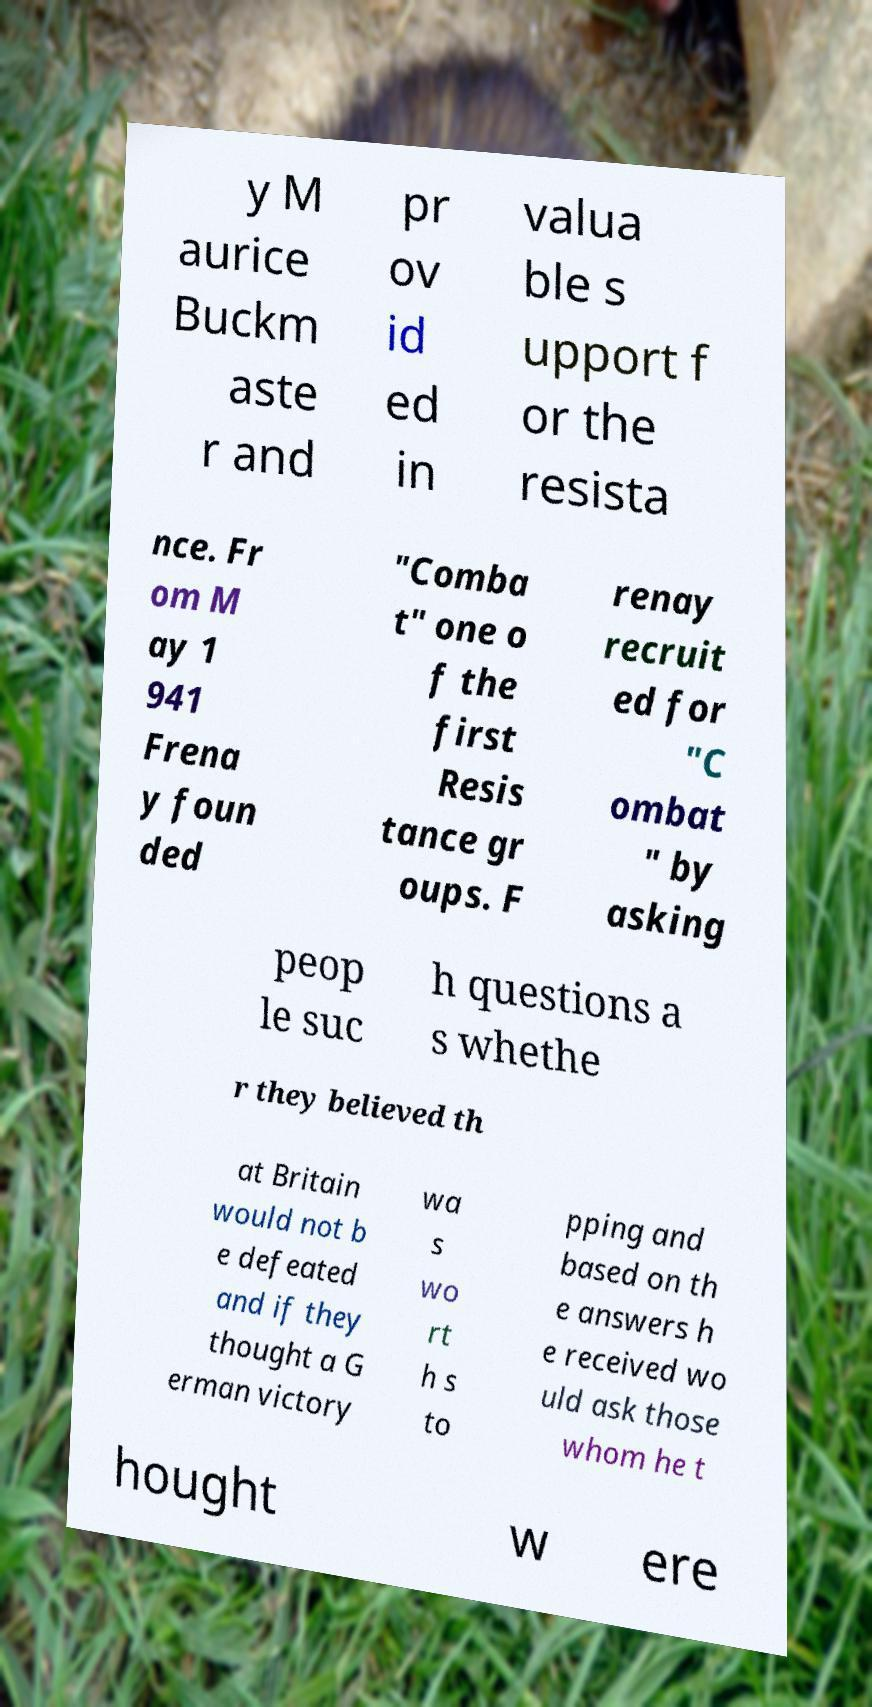There's text embedded in this image that I need extracted. Can you transcribe it verbatim? y M aurice Buckm aste r and pr ov id ed in valua ble s upport f or the resista nce. Fr om M ay 1 941 Frena y foun ded "Comba t" one o f the first Resis tance gr oups. F renay recruit ed for "C ombat " by asking peop le suc h questions a s whethe r they believed th at Britain would not b e defeated and if they thought a G erman victory wa s wo rt h s to pping and based on th e answers h e received wo uld ask those whom he t hought w ere 